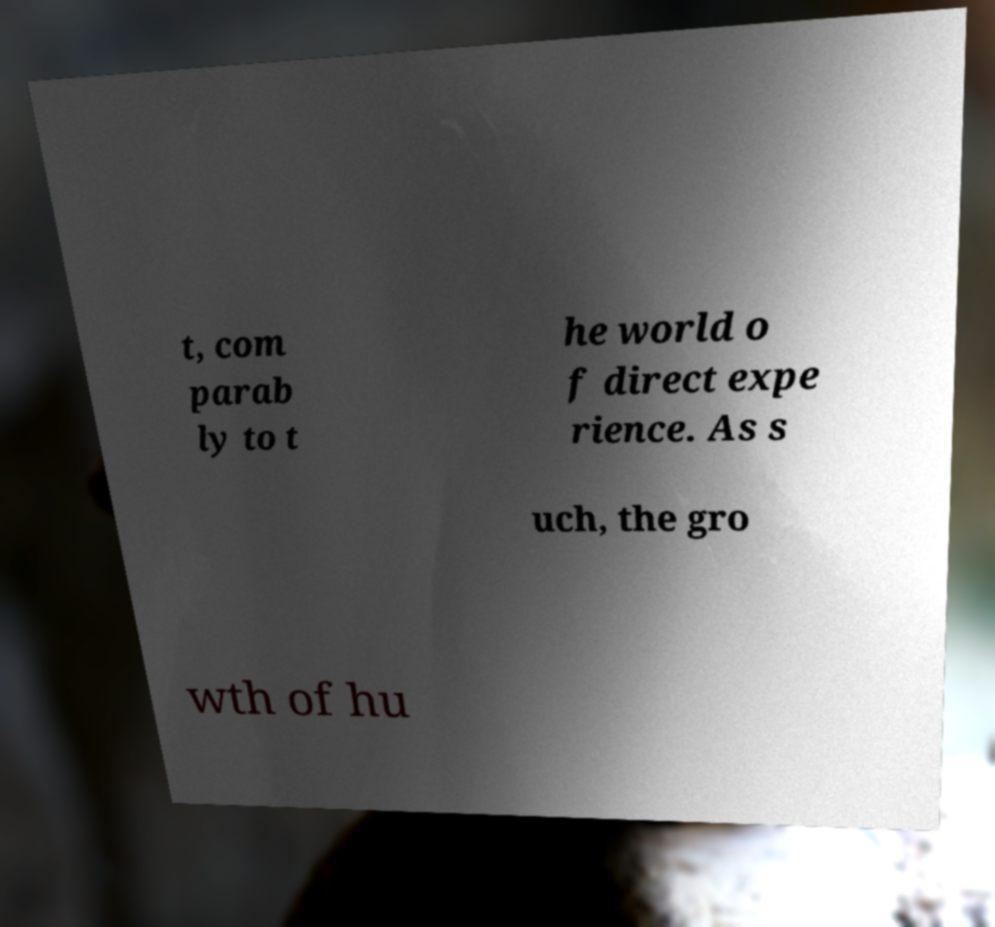What messages or text are displayed in this image? I need them in a readable, typed format. t, com parab ly to t he world o f direct expe rience. As s uch, the gro wth of hu 